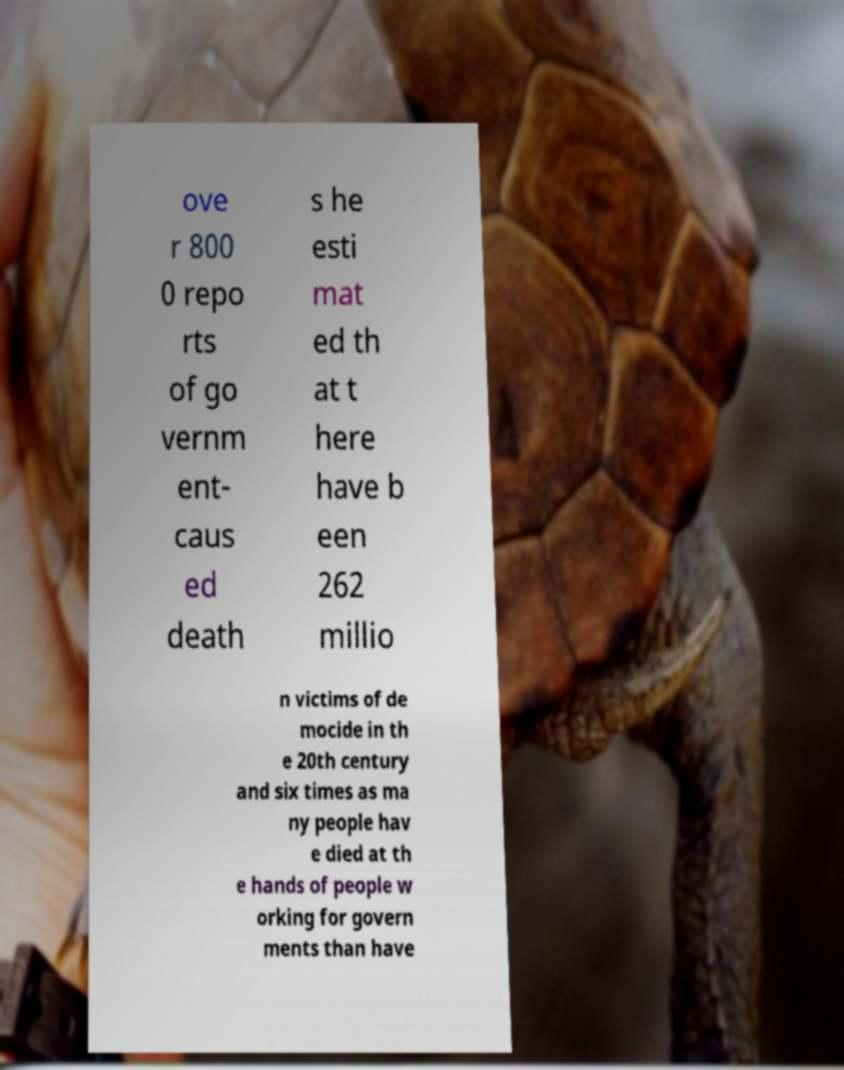Can you accurately transcribe the text from the provided image for me? ove r 800 0 repo rts of go vernm ent- caus ed death s he esti mat ed th at t here have b een 262 millio n victims of de mocide in th e 20th century and six times as ma ny people hav e died at th e hands of people w orking for govern ments than have 